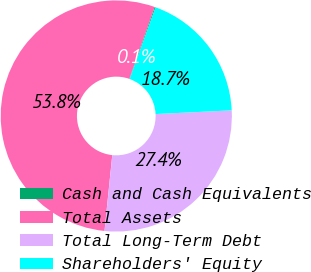Convert chart to OTSL. <chart><loc_0><loc_0><loc_500><loc_500><pie_chart><fcel>Cash and Cash Equivalents<fcel>Total Assets<fcel>Total Long-Term Debt<fcel>Shareholders' Equity<nl><fcel>0.13%<fcel>53.77%<fcel>27.4%<fcel>18.7%<nl></chart> 